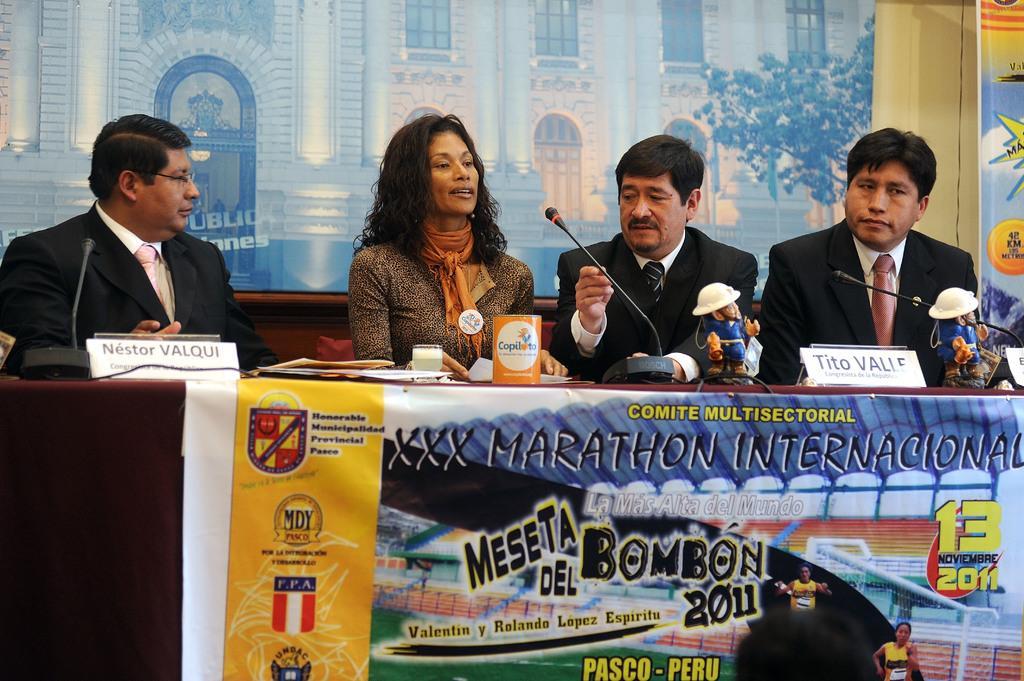Could you give a brief overview of what you see in this image? In this picture, we see four people are sitting on the chairs. In front of them, we see a table on which glass, papers, files, name boards, toys and microphones are placed. At the bottom of the picture, we see a banner with some text written on it. In the background, we see buildings and trees. It might be a poster. 